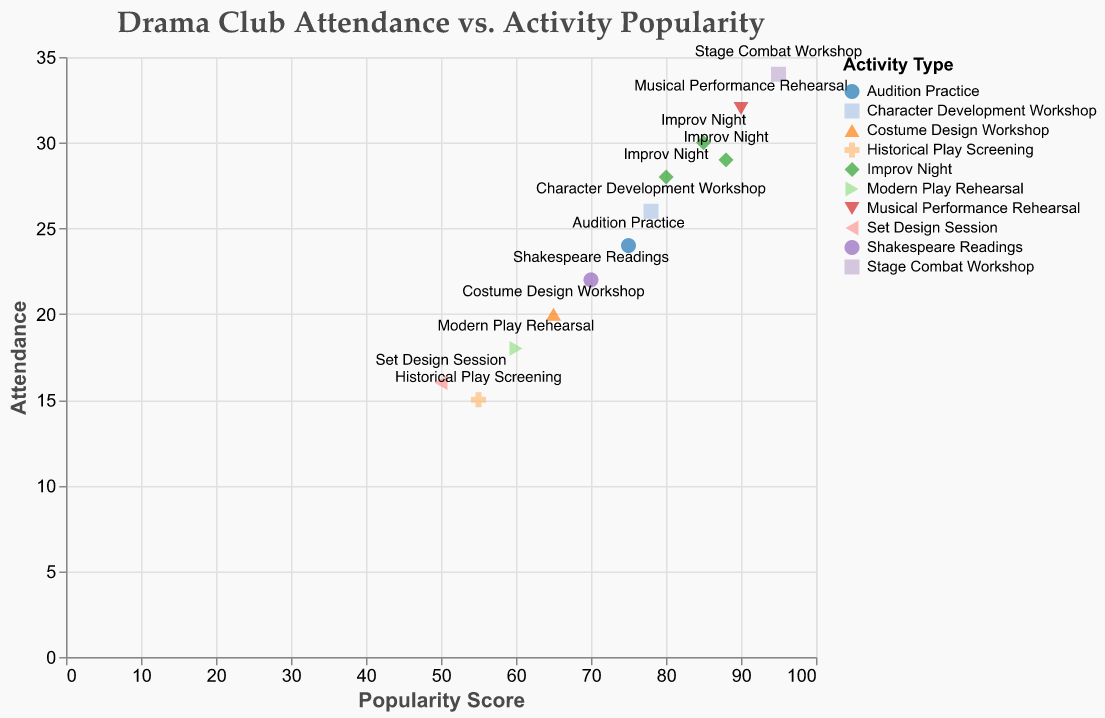What is the title of the figure? The title is displayed prominently at the top of the figure in a larger font size. It reads "Drama Club Attendance vs. Activity Popularity."
Answer: Drama Club Attendance vs. Activity Popularity What is the highest attendance recorded, and for which activity? By looking at the y-axis and the colored points in the figure, the highest attendance is recorded at a value of 34. This point corresponds to the activity labeled "Stage Combat Workshop."
Answer: Stage Combat Workshop Which activities consistently have high attendance (over 25 attendees)? Inspecting the scatter plot and identifying points where the y-axis value (Attendance) is above 25, the activities with high attendance are "Improv Night" (variously dated), "Musical Performance Rehearsal," "Stage Combat Workshop," and "Character Development Workshop."
Answer: Improv Night, Musical Performance Rehearsal, Stage Combat Workshop, Character Development Workshop What is the most popular activity based on the popularity score, and how many attended that meeting? The activity with the highest popularity score can be found by looking for the highest point on the x-axis. The "Stage Combat Workshop" has the highest popularity score of 95, with an attendance of 34.
Answer: Stage Combat Workshop, 34 Which activity has the lowest popularity score, and how is its attendance? The point with the lowest popularity score on the x-axis corresponds to the "Set Design Session," which has a popularity score of 50 and an attendance of 16.
Answer: Set Design Session, 16 Compare the attendance between "Improv Night" and "Shakespeare Readings." To compare, locate the respective points. "Improv Night" has an attendance of 30, 28, and 29 on different dates, while "Shakespeare Readings" has an attendance of 22. This shows that "Improv Night" consistently has higher attendance than "Shakespeare Readings."
Answer: Improv Night > Shakespeare Readings What is the average attendance for the "Improv Night" activity? There are three occurrences of "Improv Night" with attendances of 30, 28, and 29. To find the average, sum these values: 30 + 28 + 29 = 87. Then, divide by the number of occurrences: 87 / 3 = 29.
Answer: 29 How does the popularity score relate to attendance? By observing the scatter plot, points that are higher on the popularity score axis (x-axis) generally correspond to higher attendance values (y-axis). This indicates a positive correlation between the popularity score and attendance.
Answer: Positive correlation Which activity types cluster closely in both popularity and attendance? Points that are close together represent activities with similar values in both popularity scores and attendance. "Improv Night," "Audition Practice," and "Character Development Workshop" appear to cluster relatively closely, indicating these activities have similar popularity and attendance metrics.
Answer: Improv Night, Audition Practice, Character Development Workshop 